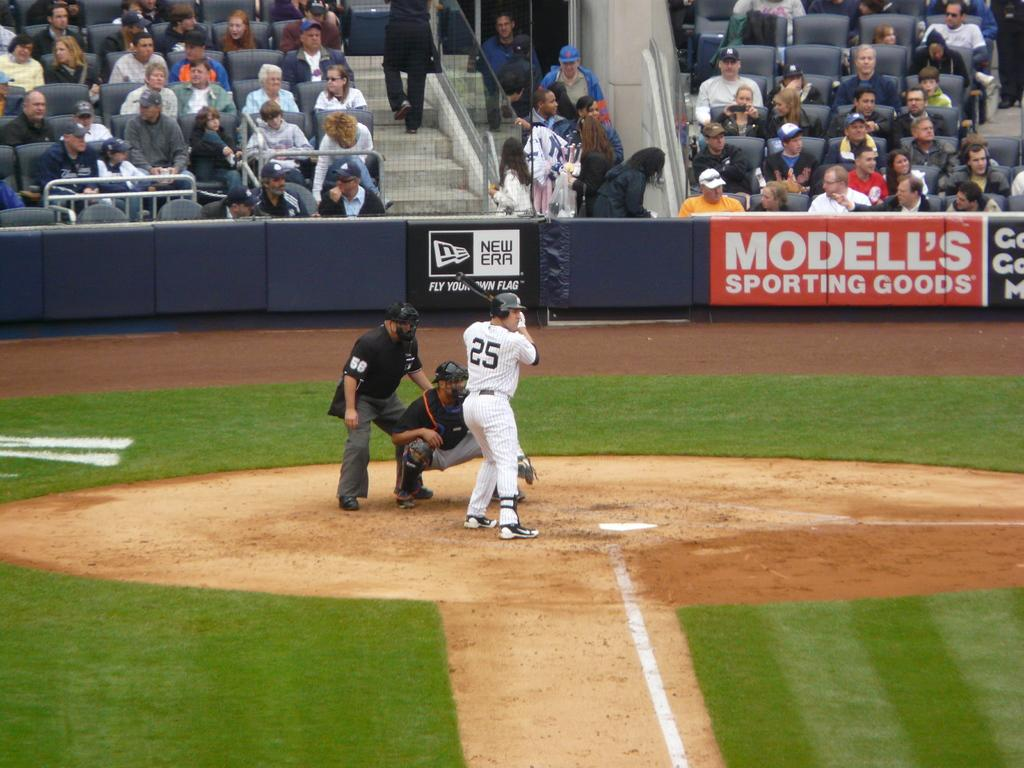Provide a one-sentence caption for the provided image. A batter, number 25 is waiting for the pitch in the baseball game with a sign advertising Modell's Sporting Goods to the right. 